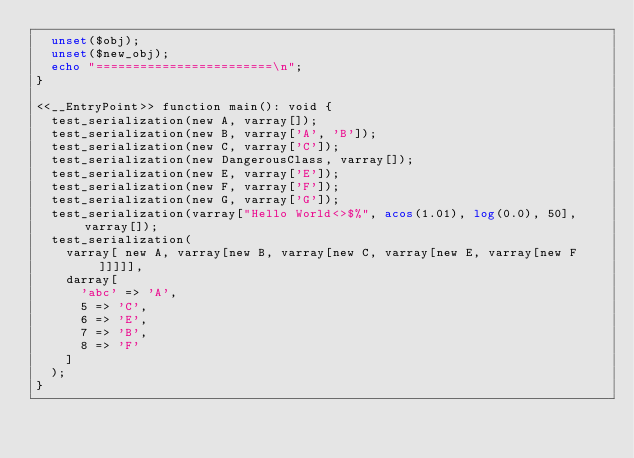<code> <loc_0><loc_0><loc_500><loc_500><_PHP_>  unset($obj);
  unset($new_obj);
  echo "========================\n";
}

<<__EntryPoint>> function main(): void {
  test_serialization(new A, varray[]);
  test_serialization(new B, varray['A', 'B']);
  test_serialization(new C, varray['C']);
  test_serialization(new DangerousClass, varray[]);
  test_serialization(new E, varray['E']);
  test_serialization(new F, varray['F']);
  test_serialization(new G, varray['G']);
  test_serialization(varray["Hello World<>$%", acos(1.01), log(0.0), 50], varray[]);
  test_serialization(
    varray[ new A, varray[new B, varray[new C, varray[new E, varray[new F]]]]],
    darray[
      'abc' => 'A',
      5 => 'C',
      6 => 'E',
      7 => 'B',
      8 => 'F'
    ]
  );
}
</code> 